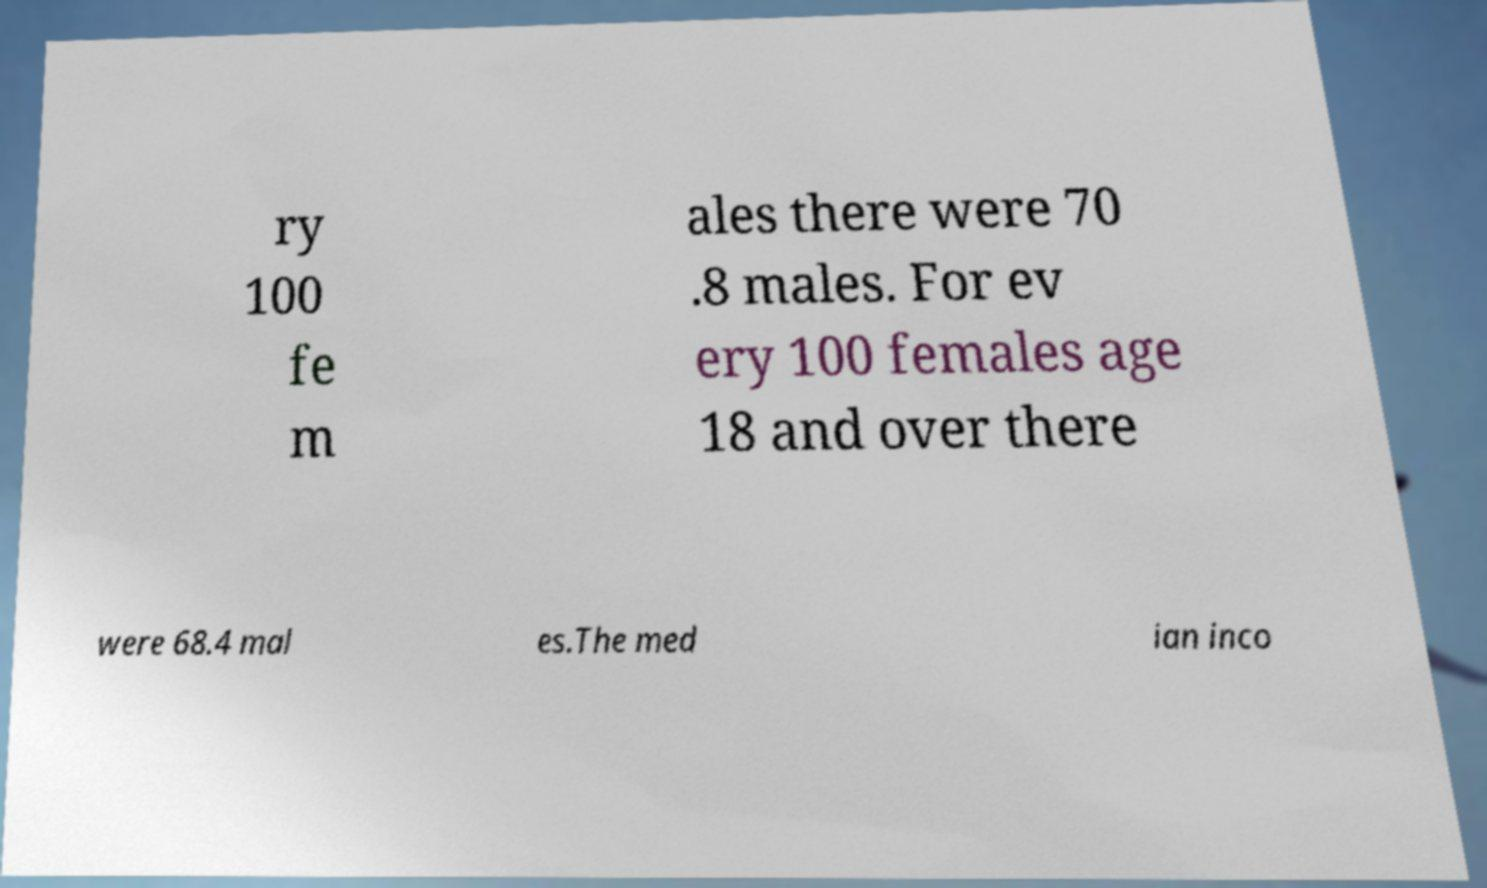There's text embedded in this image that I need extracted. Can you transcribe it verbatim? ry 100 fe m ales there were 70 .8 males. For ev ery 100 females age 18 and over there were 68.4 mal es.The med ian inco 